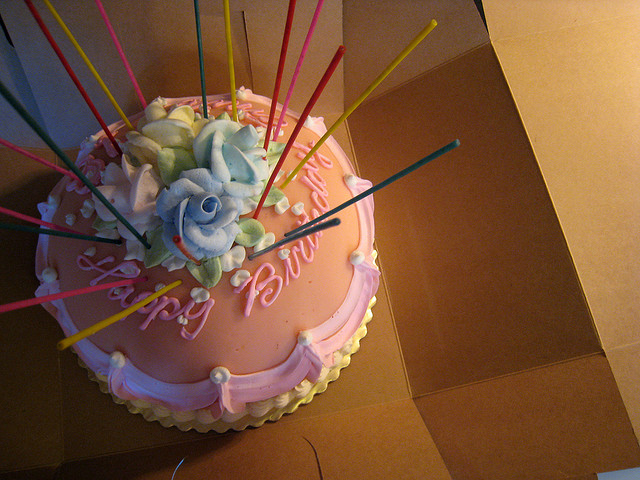Read all the text in this image. Happy Birthday 